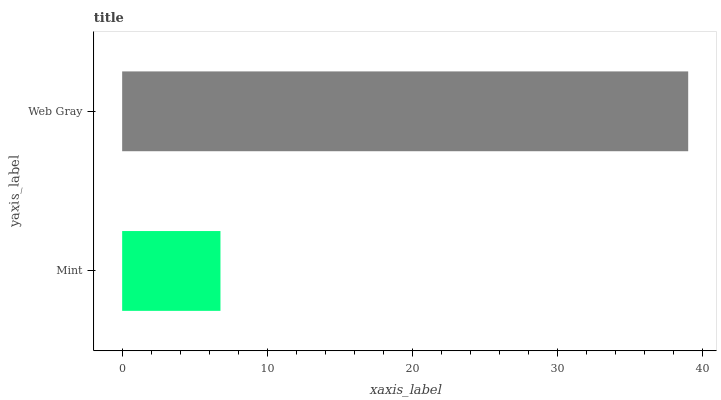Is Mint the minimum?
Answer yes or no. Yes. Is Web Gray the maximum?
Answer yes or no. Yes. Is Web Gray the minimum?
Answer yes or no. No. Is Web Gray greater than Mint?
Answer yes or no. Yes. Is Mint less than Web Gray?
Answer yes or no. Yes. Is Mint greater than Web Gray?
Answer yes or no. No. Is Web Gray less than Mint?
Answer yes or no. No. Is Web Gray the high median?
Answer yes or no. Yes. Is Mint the low median?
Answer yes or no. Yes. Is Mint the high median?
Answer yes or no. No. Is Web Gray the low median?
Answer yes or no. No. 